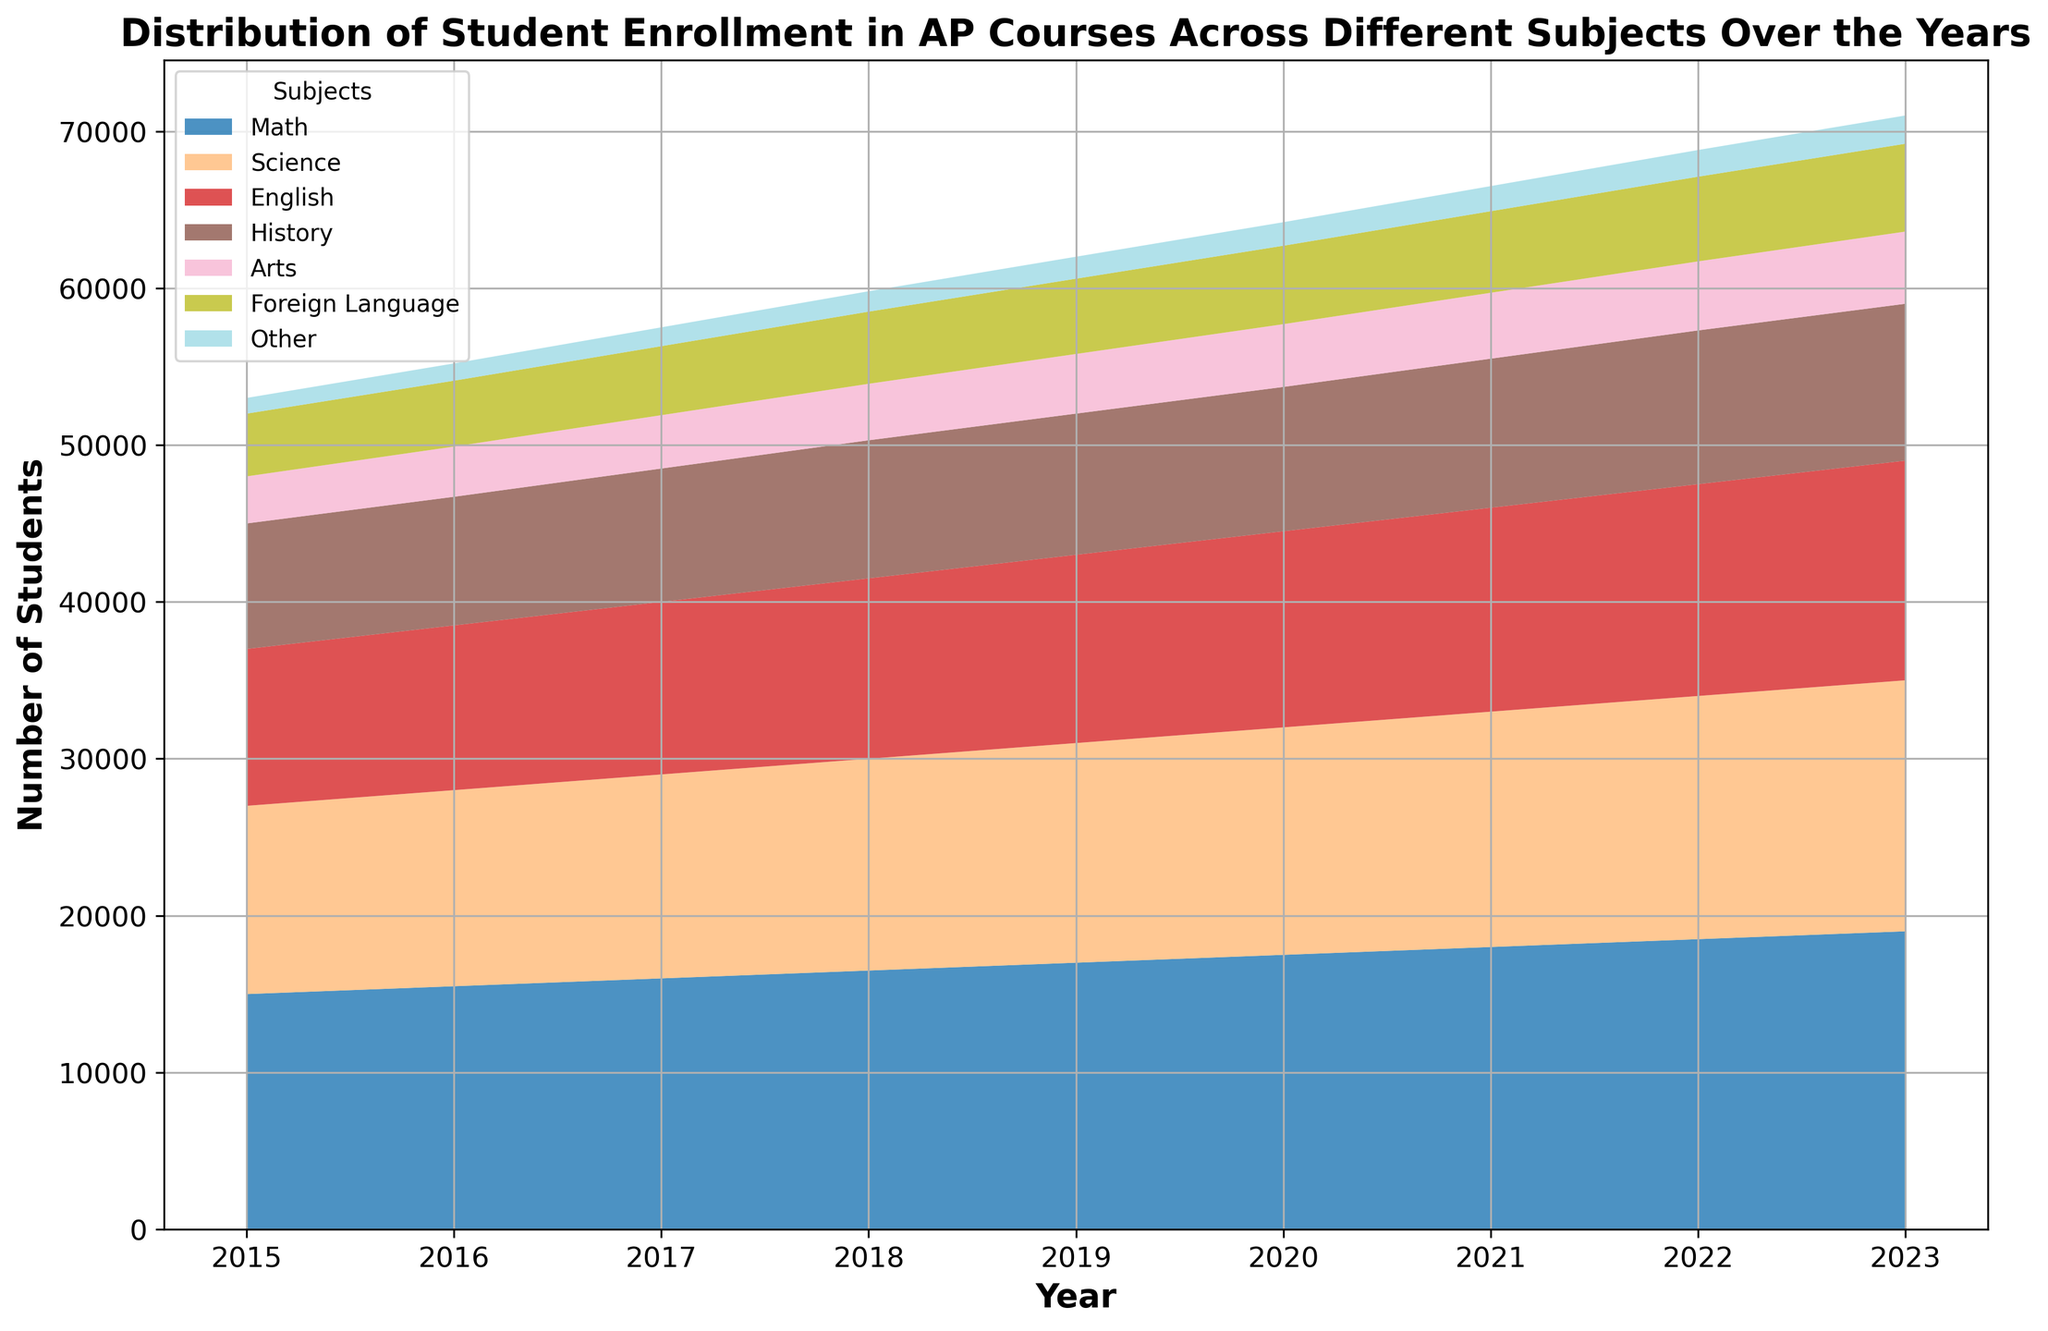What's the highest number of students enrolled in any subject in 2023? Check the values for each subject in 2023, the highest is for Math with 19000 students.
Answer: 19000 How has the enrollment in Foreign Language courses changed from 2015 to 2023? Compare the Foreign Language enrollment in 2015 (4000) and 2023 (5600). The increase is 5600 - 4000 = 1600.
Answer: Increased by 1600 In which year did the number of students enrolled in Science first exceed 14000? Look at the Science enrollment data over the years. The year it first exceeds 14000 is 2019.
Answer: 2019 Which subject had the lowest student enrollment in 2018, and how many students were enrolled? Check the data for 2018 and find that 'Other' had the lowest enrollment with 1300 students.
Answer: Other, 1300 By how much did the number of students enrolled in English courses increase from 2016 to 2020? English enrollment in 2016 was 10500, and in 2020 it was 12500. The increase is 12500 - 10500 = 2000.
Answer: 2000 Compare the enrollment trends for History and Arts from 2015 to 2023. Which subject saw a greater relative increase? History increased from 8000 to 10000 (2000 increase). Arts increased from 3000 to 4600 (1600 increase). Calculating relative increases: History: (2000/8000) = 25%, Arts: (1600/3000) ≈ 53%. Arts had a greater relative increase.
Answer: Arts In which year did enrollment in Math courses increase by the largest amount compared to the previous year? Calculate the yearly increases for Math: 2016: 500, 2017: 500, 2018: 500, 2019: 500, 2020: 500, 2021: 500, 2022: 500, 2023: 500. All years show an increase of 500.
Answer: 2016 (or any other year, as all increases are 500) What's the total number of students enrolled in all subjects combined in 2017? Sum all the enrollments in 2017: 16000 (Math) + 13000 (Science) + 11000 (English) + 8500 (History) + 3400 (Arts) + 4400 (Foreign Language) + 1200 (Other) = 57500.
Answer: 57500 Which subject showed the smallest growth in student numbers from 2015 to 2023? Calculate the growth for each subject: Math: 4000, Science: 4000, English: 4000, History: 2000, Arts: 1600, Foreign Language: 1600, Other: 800. 'Other' had the smallest growth.
Answer: Other Identify any year where the sum of enrollments in Arts and Foreign Language exceeds the enrollment in English. Compare the sum of Arts and Foreign Language with English for each year. None of the years have a sum that exceeds the enrollment in English.
Answer: None 